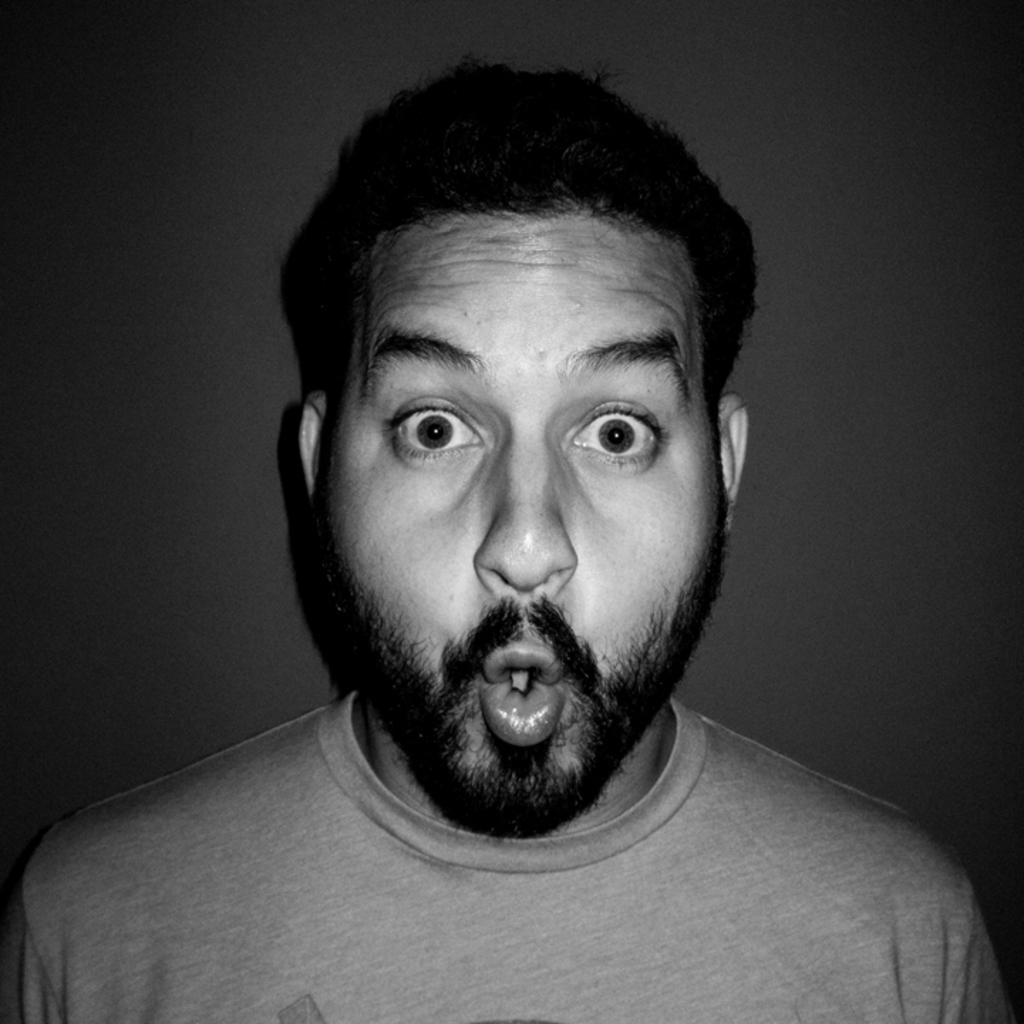What is the main subject of the image? There is a person in the image. What color scheme is used in the image? The image is in black and white. Can you see any visible veins on the person's hands in the image? There is no information provided about the person's hands or the presence of veins in the image. --- 